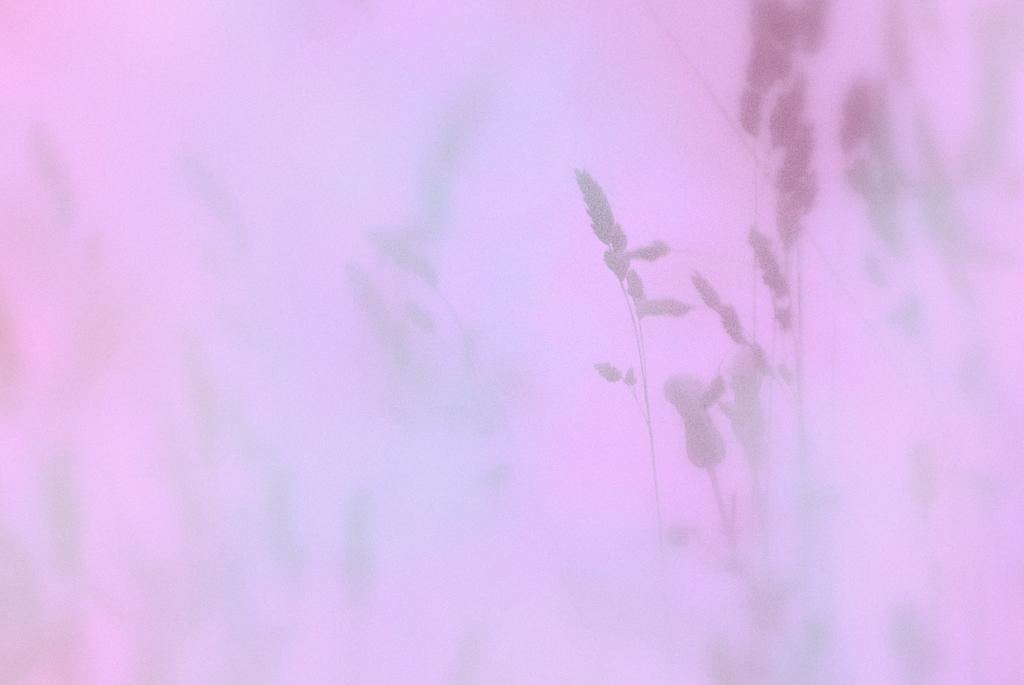Please provide a concise description of this image. This picture is blur and pink, in this picture we can see plants. 